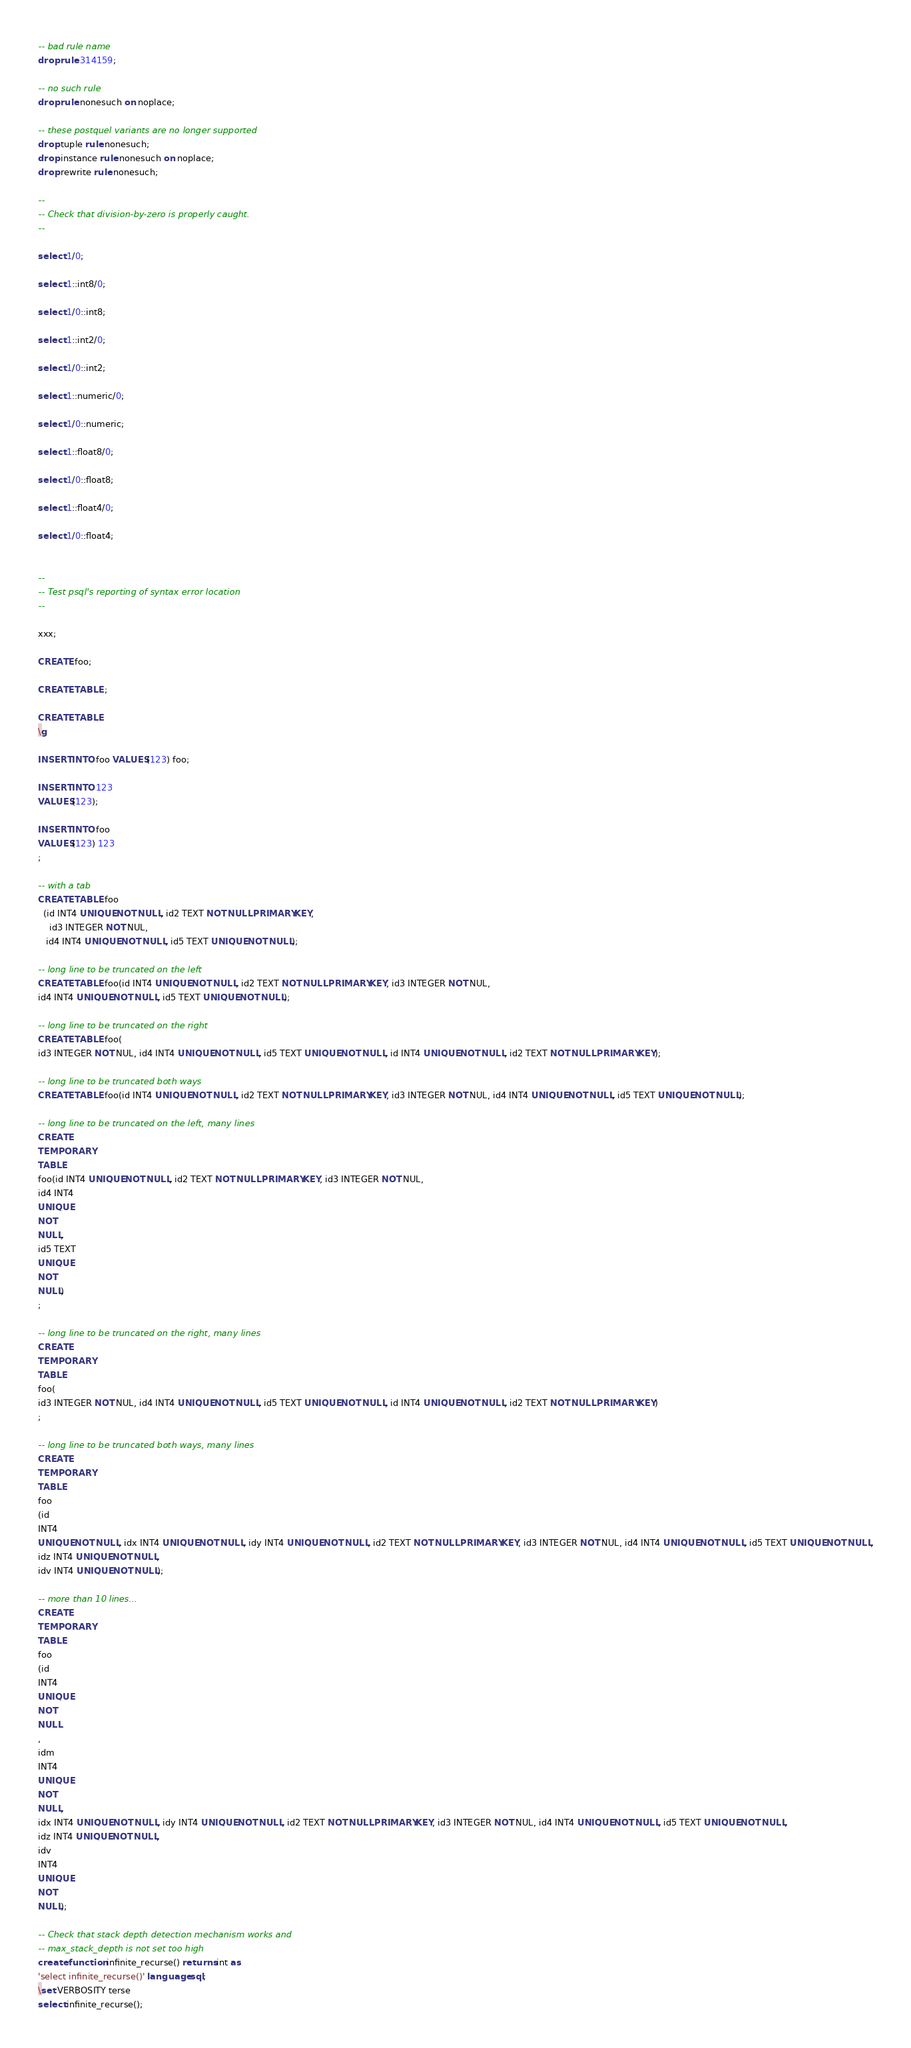Convert code to text. <code><loc_0><loc_0><loc_500><loc_500><_SQL_>-- bad rule name
drop rule 314159;

-- no such rule
drop rule nonesuch on noplace;

-- these postquel variants are no longer supported
drop tuple rule nonesuch;
drop instance rule nonesuch on noplace;
drop rewrite rule nonesuch;

--
-- Check that division-by-zero is properly caught.
--

select 1/0;

select 1::int8/0;

select 1/0::int8;

select 1::int2/0;

select 1/0::int2;

select 1::numeric/0;

select 1/0::numeric;

select 1::float8/0;

select 1/0::float8;

select 1::float4/0;

select 1/0::float4;


--
-- Test psql's reporting of syntax error location
--

xxx;

CREATE foo;

CREATE TABLE ;

CREATE TABLE
\g

INSERT INTO foo VALUES(123) foo;

INSERT INTO 123
VALUES(123);

INSERT INTO foo
VALUES(123) 123
;

-- with a tab
CREATE TABLE foo
  (id INT4 UNIQUE NOT NULL, id2 TEXT NOT NULL PRIMARY KEY,
	id3 INTEGER NOT NUL,
   id4 INT4 UNIQUE NOT NULL, id5 TEXT UNIQUE NOT NULL);

-- long line to be truncated on the left
CREATE TABLE foo(id INT4 UNIQUE NOT NULL, id2 TEXT NOT NULL PRIMARY KEY, id3 INTEGER NOT NUL,
id4 INT4 UNIQUE NOT NULL, id5 TEXT UNIQUE NOT NULL);

-- long line to be truncated on the right
CREATE TABLE foo(
id3 INTEGER NOT NUL, id4 INT4 UNIQUE NOT NULL, id5 TEXT UNIQUE NOT NULL, id INT4 UNIQUE NOT NULL, id2 TEXT NOT NULL PRIMARY KEY);

-- long line to be truncated both ways
CREATE TABLE foo(id INT4 UNIQUE NOT NULL, id2 TEXT NOT NULL PRIMARY KEY, id3 INTEGER NOT NUL, id4 INT4 UNIQUE NOT NULL, id5 TEXT UNIQUE NOT NULL);

-- long line to be truncated on the left, many lines
CREATE
TEMPORARY
TABLE
foo(id INT4 UNIQUE NOT NULL, id2 TEXT NOT NULL PRIMARY KEY, id3 INTEGER NOT NUL,
id4 INT4
UNIQUE
NOT
NULL,
id5 TEXT
UNIQUE
NOT
NULL)
;

-- long line to be truncated on the right, many lines
CREATE
TEMPORARY
TABLE
foo(
id3 INTEGER NOT NUL, id4 INT4 UNIQUE NOT NULL, id5 TEXT UNIQUE NOT NULL, id INT4 UNIQUE NOT NULL, id2 TEXT NOT NULL PRIMARY KEY)
;

-- long line to be truncated both ways, many lines
CREATE
TEMPORARY
TABLE
foo
(id
INT4
UNIQUE NOT NULL, idx INT4 UNIQUE NOT NULL, idy INT4 UNIQUE NOT NULL, id2 TEXT NOT NULL PRIMARY KEY, id3 INTEGER NOT NUL, id4 INT4 UNIQUE NOT NULL, id5 TEXT UNIQUE NOT NULL,
idz INT4 UNIQUE NOT NULL,
idv INT4 UNIQUE NOT NULL);

-- more than 10 lines...
CREATE
TEMPORARY
TABLE
foo
(id
INT4
UNIQUE
NOT
NULL
,
idm
INT4
UNIQUE
NOT
NULL,
idx INT4 UNIQUE NOT NULL, idy INT4 UNIQUE NOT NULL, id2 TEXT NOT NULL PRIMARY KEY, id3 INTEGER NOT NUL, id4 INT4 UNIQUE NOT NULL, id5 TEXT UNIQUE NOT NULL,
idz INT4 UNIQUE NOT NULL,
idv
INT4
UNIQUE
NOT
NULL);

-- Check that stack depth detection mechanism works and
-- max_stack_depth is not set too high
create function infinite_recurse() returns int as
'select infinite_recurse()' language sql;
\set VERBOSITY terse
select infinite_recurse();
</code> 